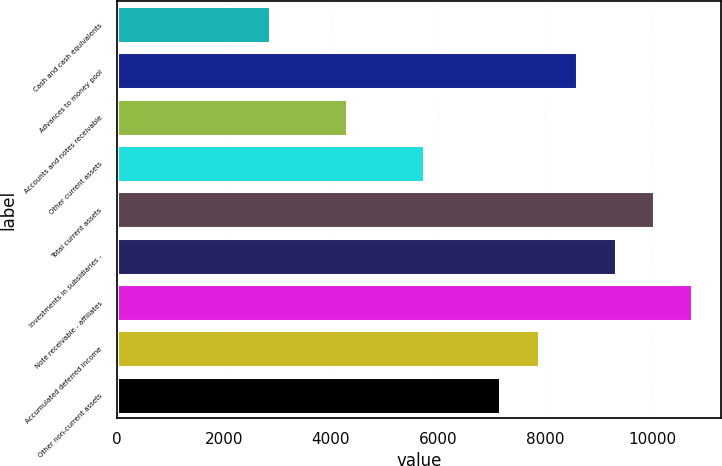Convert chart. <chart><loc_0><loc_0><loc_500><loc_500><bar_chart><fcel>Cash and cash equivalents<fcel>Advances to money pool<fcel>Accounts and notes receivable<fcel>Other current assets<fcel>Total current assets<fcel>Investments in subsidiaries -<fcel>Note receivable - affiliates<fcel>Accumulated deferred income<fcel>Other non-current assets<nl><fcel>2866.4<fcel>8595.2<fcel>4298.6<fcel>5730.8<fcel>10027.4<fcel>9311.3<fcel>10743.5<fcel>7879.1<fcel>7163<nl></chart> 